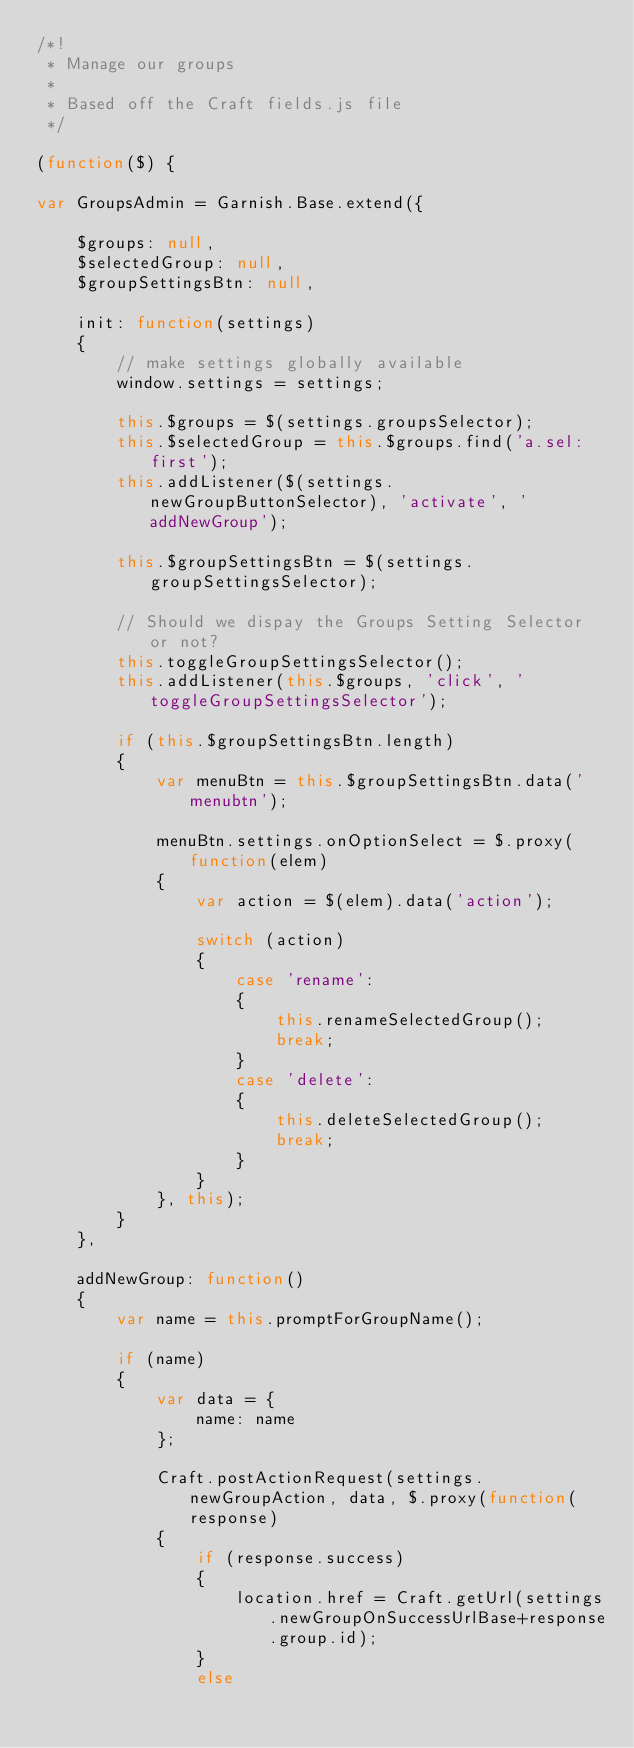<code> <loc_0><loc_0><loc_500><loc_500><_JavaScript_>/*!
 * Manage our groups
 * 
 * Based off the Craft fields.js file
 */

(function($) {

var GroupsAdmin = Garnish.Base.extend({

	$groups: null,
	$selectedGroup: null,
	$groupSettingsBtn: null,

	init: function(settings)
	{
		// make settings globally available
		window.settings = settings;

		this.$groups = $(settings.groupsSelector);
		this.$selectedGroup = this.$groups.find('a.sel:first');
		this.addListener($(settings.newGroupButtonSelector), 'activate', 'addNewGroup');

		this.$groupSettingsBtn = $(settings.groupSettingsSelector);

		// Should we dispay the Groups Setting Selector or not?
		this.toggleGroupSettingsSelector();
		this.addListener(this.$groups, 'click', 'toggleGroupSettingsSelector');
	
		if (this.$groupSettingsBtn.length)
		{
			var menuBtn = this.$groupSettingsBtn.data('menubtn');
			
			menuBtn.settings.onOptionSelect = $.proxy(function(elem)
			{
				var action = $(elem).data('action');

				switch (action)
				{
					case 'rename':
					{
						this.renameSelectedGroup();
						break;
					}
					case 'delete':
					{
						this.deleteSelectedGroup();
						break;
					}
				}
			}, this);
		}
	},

	addNewGroup: function()
	{
		var name = this.promptForGroupName();

		if (name)
		{
			var data = {
				name: name
			};

			Craft.postActionRequest(settings.newGroupAction, data, $.proxy(function(response)
			{
				if (response.success)
				{
					location.href = Craft.getUrl(settings.newGroupOnSuccessUrlBase+response.group.id);
				}
				else</code> 